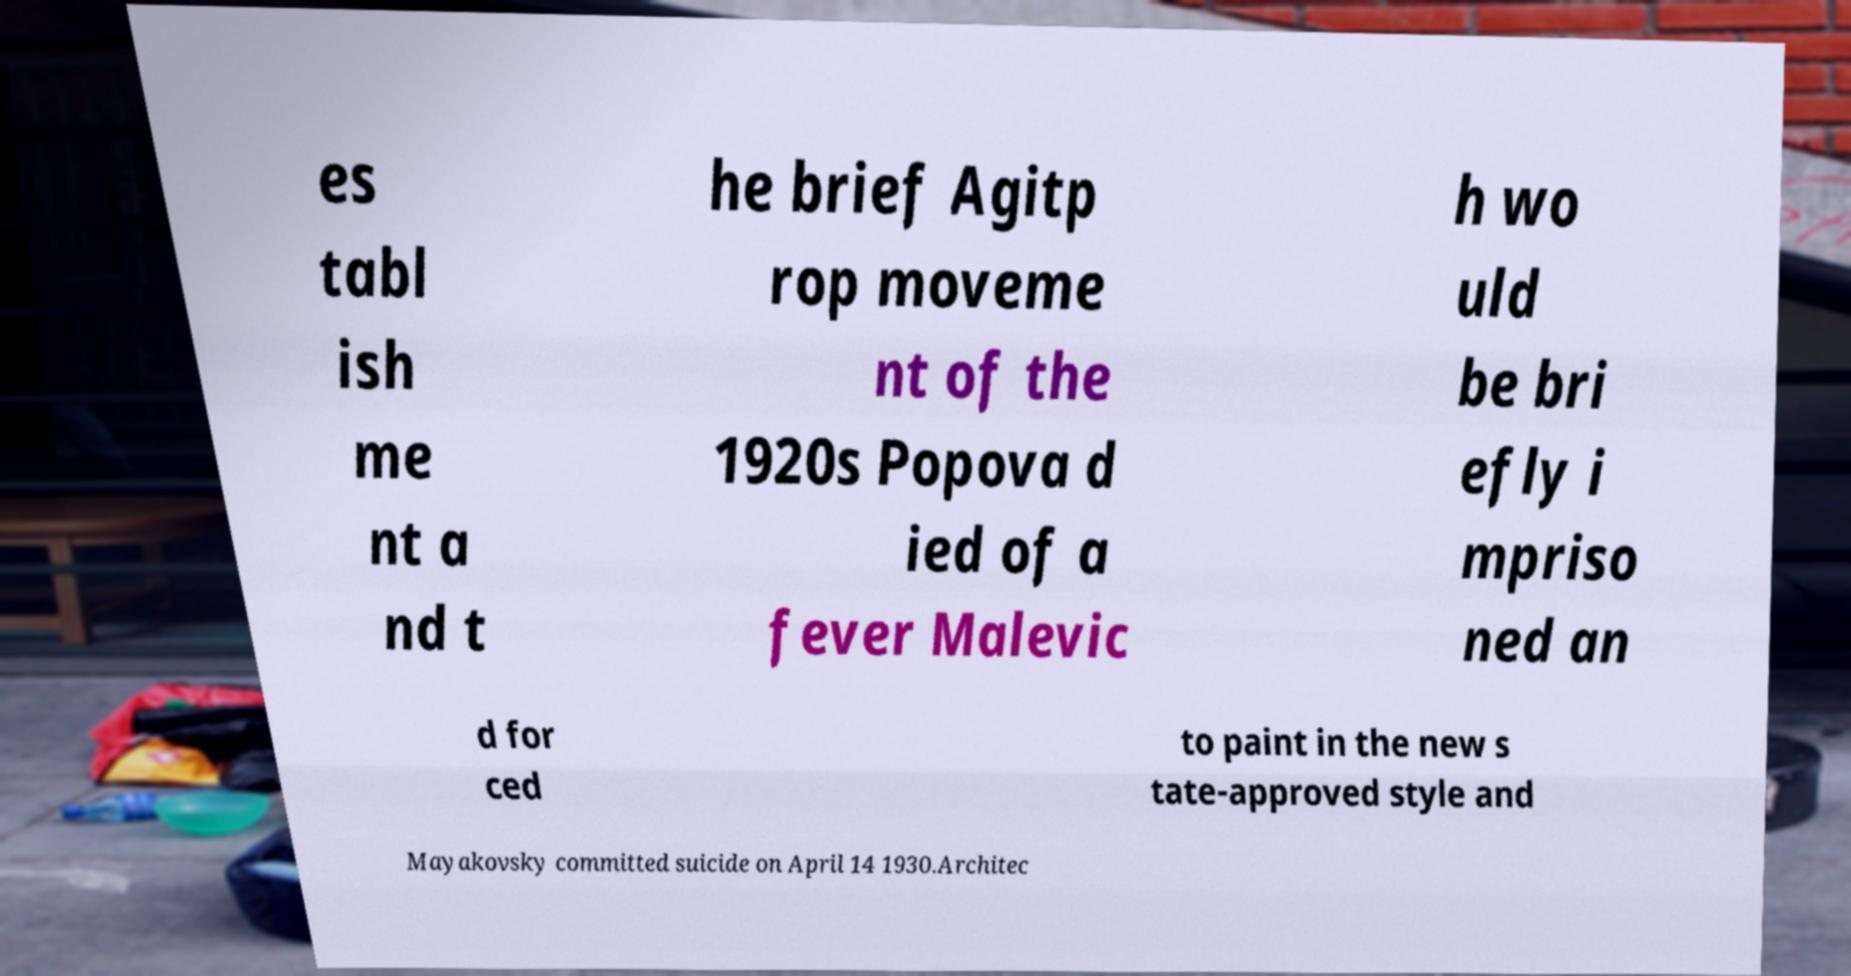What messages or text are displayed in this image? I need them in a readable, typed format. es tabl ish me nt a nd t he brief Agitp rop moveme nt of the 1920s Popova d ied of a fever Malevic h wo uld be bri efly i mpriso ned an d for ced to paint in the new s tate-approved style and Mayakovsky committed suicide on April 14 1930.Architec 